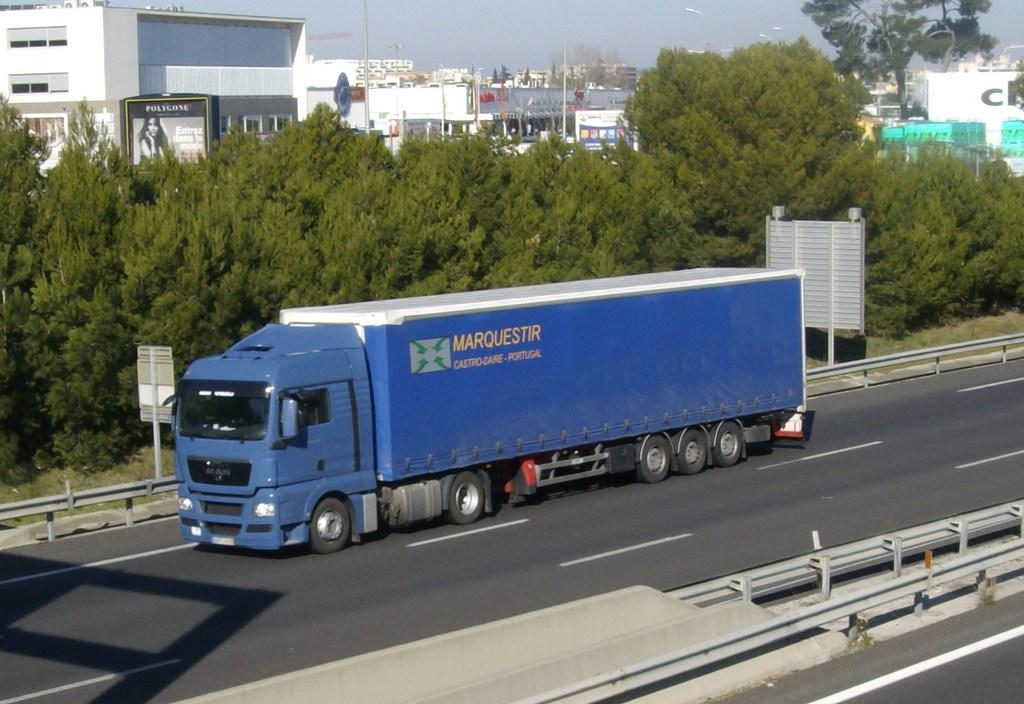What is on the road in the image? There is a vehicle on the road in the image. What type of natural elements can be seen in the image? There are trees in the image. What type of man-made structures are present in the image? There are buildings in the image. What type of vertical structures can be seen in the image? There are poles in the image. What is visible in the background of the image? The sky is visible in the background of the image. Where is the pail located in the image? There is no pail present in the image. What type of manager is depicted in the image? There is no manager depicted in the image. 